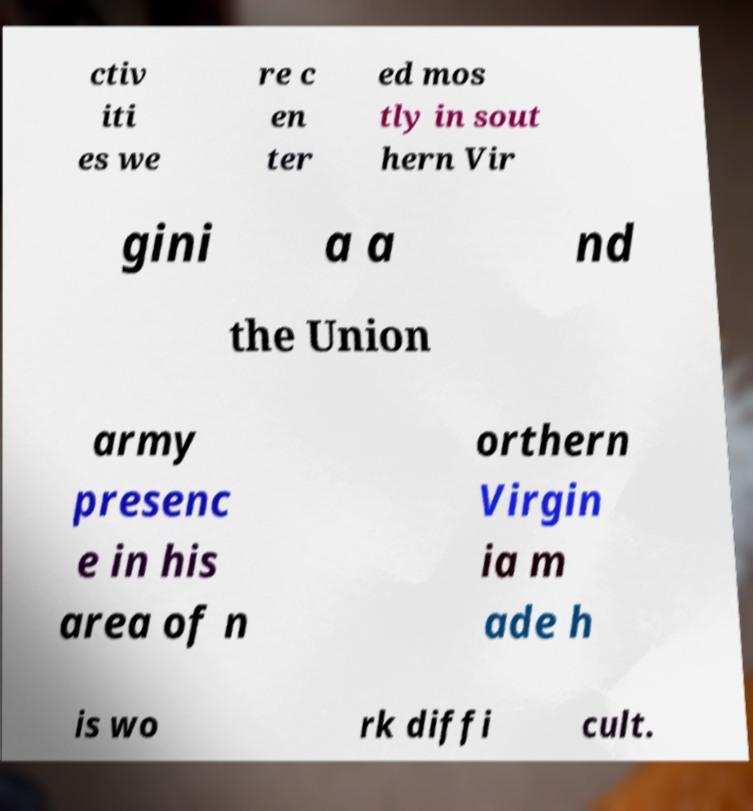There's text embedded in this image that I need extracted. Can you transcribe it verbatim? ctiv iti es we re c en ter ed mos tly in sout hern Vir gini a a nd the Union army presenc e in his area of n orthern Virgin ia m ade h is wo rk diffi cult. 